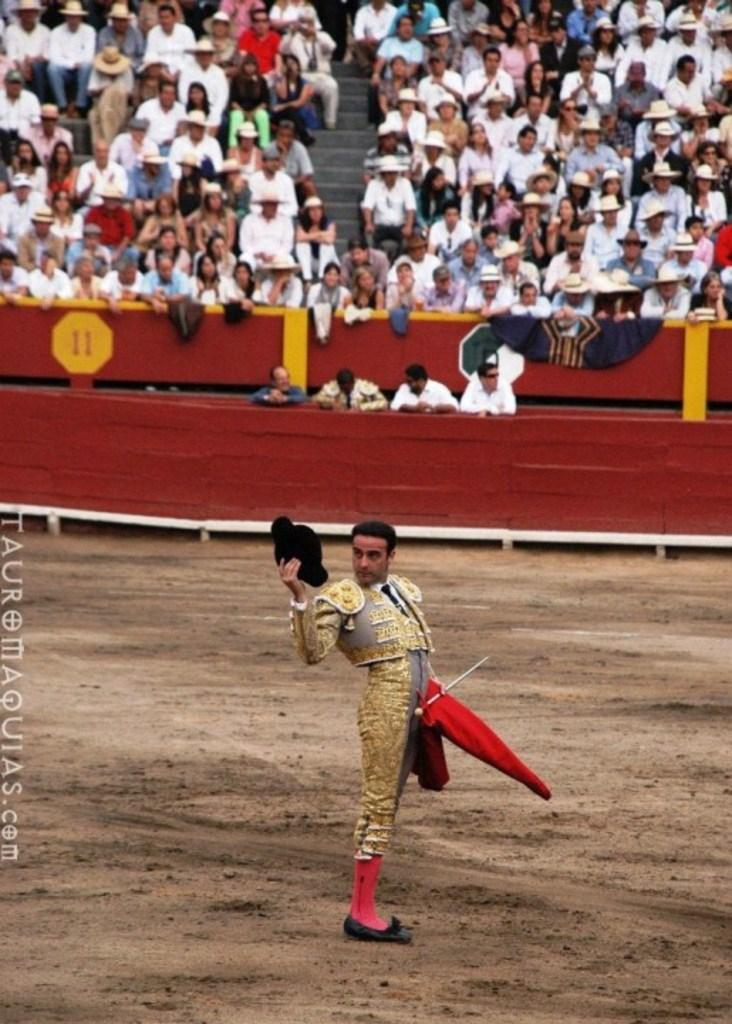Who or what can be seen in the image? There are people in the image. What architectural feature is present in the image? There are stairs in the image. What type of furniture is visible in the image? There are chairs in the image. What accessory is the man in the front holding? The man in the front is holding a black color hat. Are there any police officers present in the image? There is no mention of police officers in the provided facts, so it cannot be determined if they are present in the image. 